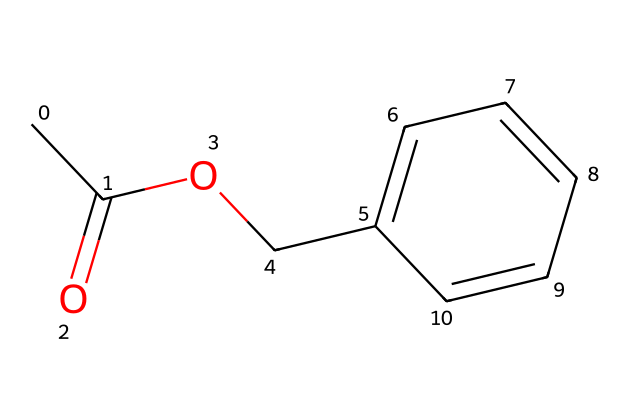What is the common name of this chemical? The SMILES representation indicates that this ester is benzyl acetate, which is derived from benzyl alcohol and acetic acid. The structure reflects its common usage in fragrances.
Answer: benzyl acetate How many carbon atoms are in benzyl acetate? The SMILES notation shows that there are nine carbon atoms present in the molecule, counting each carbon in both the aromatic ring and the aliphatic portion.
Answer: nine What functional group characterizes benzyl acetate? Benzyl acetate contains an ester functional group, which is identifiable from the carbonyl (C=O) and the ether (C-O) components found in the structure.
Answer: ester How many hydrogen atoms are in benzyl acetate? By analyzing the SMILES representation, we can deduce that benzyl acetate has ten hydrogen atoms based on the structure of the carbon atoms and the functional groups.
Answer: ten What property does the presence of the aromatic ring suggest about benzyl acetate? The presence of the aromatic benzene ring typically indicates stability and a pleasant floral scent, which contributes to its use in perfumes.
Answer: pleasant floral scent Which part of the structure determines the ester classification? The ester classification is determined by the carbonyl (C=O) that is directly adjacent to the oxygen atom (O) connected to a carbon chain, characteristic of esters.
Answer: carbonyl and ether 